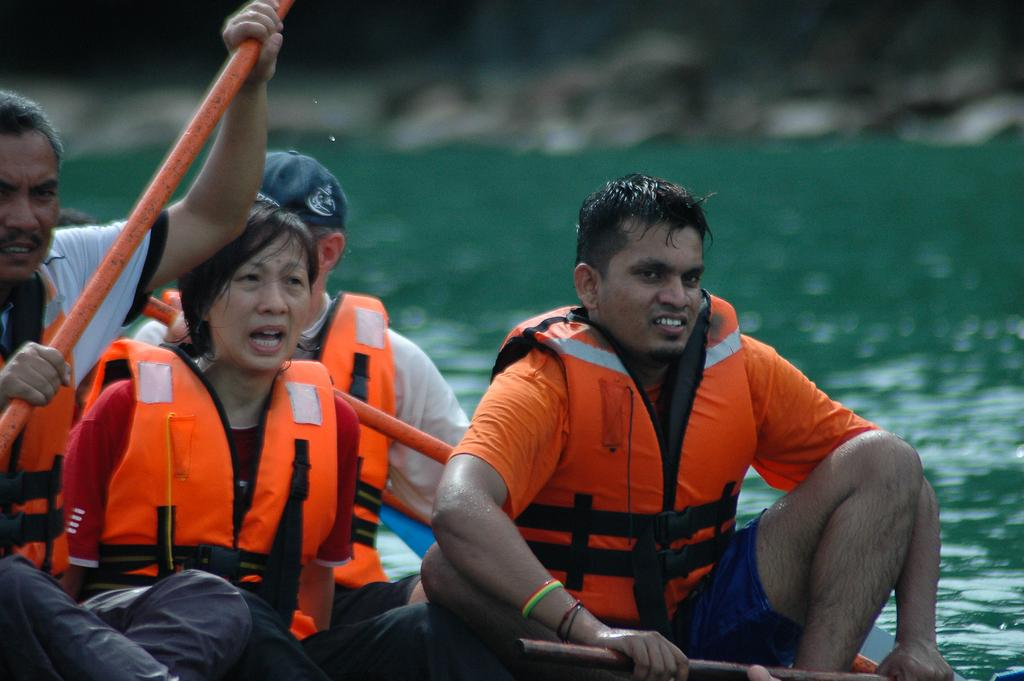Who is present in the image? There are people in the image. What are the people wearing? The people are wearing hi-viz jackets. What activity are the people engaged in? The people are rafting on the water. What type of stitch is being used to hold the quilt together in the image? There is no quilt present in the image, so it is not possible to determine what type of stitch is being used. 